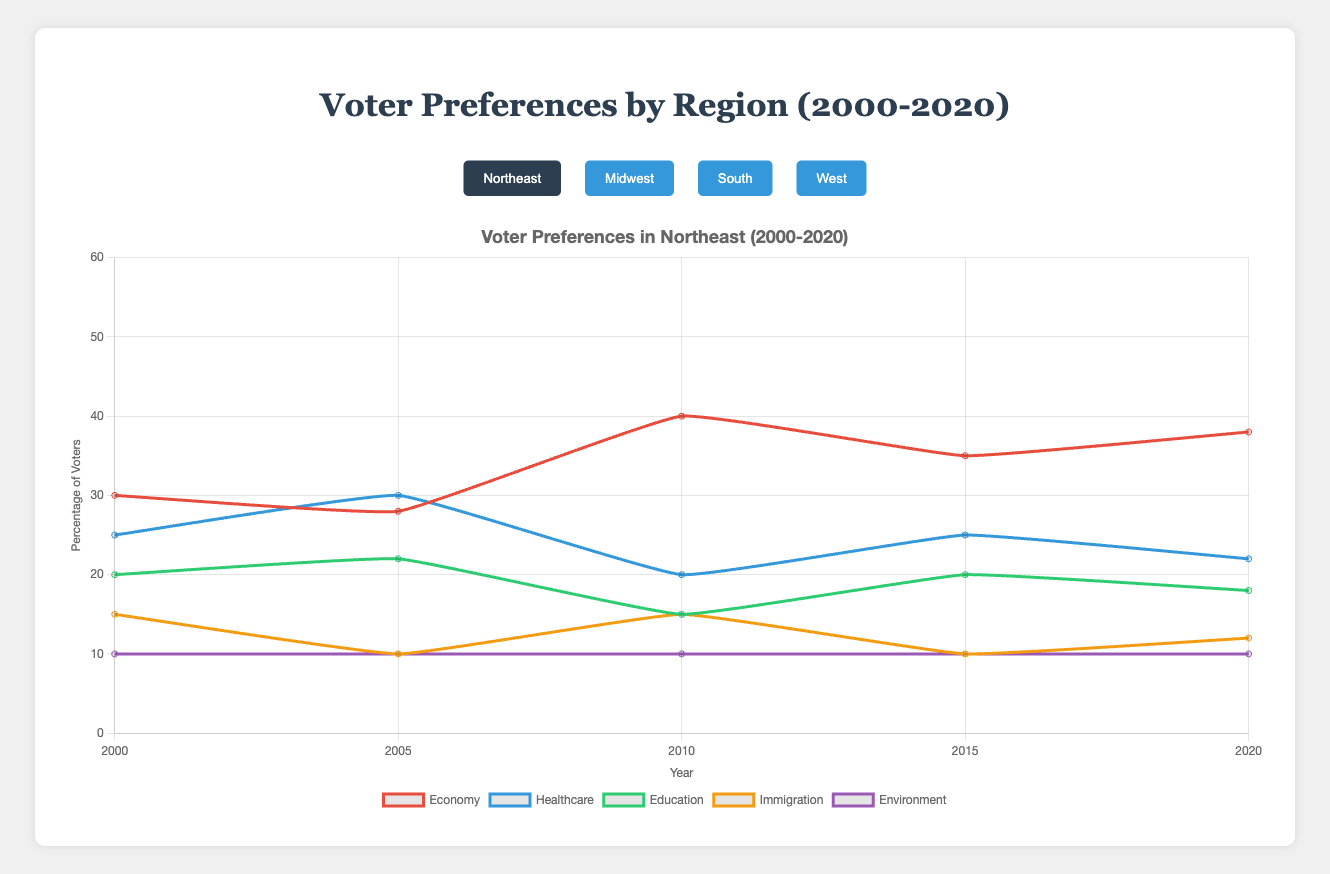Which issue had the highest voter preference in the Northeast in 2010? By examining the line chart for the Northeast in 2010, we can observe that the economy had the highest voter preference.
Answer: Economy How did the importance of healthcare change from 2000 to 2020 in the South? In the South, healthcare stayed relatively stable with a voter preference of 15% in both 2000 and 2020, only varying slightly during the intervening years.
Answer: Remained stable Which region saw the biggest increase in the importance of the economy from 2000 to 2020? By looking at all four regions over time, it is evident that the South saw the economy's importance increase from 40% in 2000 to 50% in 2020, the largest increase among the regions.
Answer: South What was the combined voter preference percentage for education and immigration in the Midwest in 2015? In the Midwest in 2015, the voter preference for education was 25% and for immigration was 10%. Adding these together gives us 25% + 10% = 35%.
Answer: 35% In 2005, which issue was less important than healthcare but more important than immigration in the West? In the West in 2005, healthcare was at 28%, immigration at 10%, and education at 22%. Therefore, education was less important than healthcare but more important than immigration.
Answer: Education Which region had the least importance placed on the environment consistently from 2000 to 2020? By examining the line chart, the Midwest consistently showed the lowest importance placed on the environment from 2000 to 2020, ending with 5% in 2020.
Answer: Midwest How did the voter preference for the economy in the Northeast in 2000 compare to the Midwest in 2020? In 2000, the voter preference for the economy in the Northeast was 30%. In 2020, the voter preference for the economy in the Midwest was 42%. Therefore, the Midwest in 2020 was significantly higher by 12%.
Answer: Midwest in 2020 was higher What was the average voter preference for education in the Northeast across all years? In the Northeast, voter preferences for education across the years were 20%, 22%, 15%, 20%, and 18%. The average is calculated as (20 + 22 + 15 + 20 + 18) / 5, which equals 19%.
Answer: 19% Which issue saw a decrease in voter preference in the West from 2005 to 2020? By examining the chart data for the West, immigration decreased from 10% in 2005 to 8% in 2020.
Answer: Immigration What is the difference in voter preference for healthcare between the West and the Northeast in 2015? In 2015, healthcare in the West was at 28% and 25% in the Northeast. The difference is 28% - 25%, which equals 3%.
Answer: 3% 